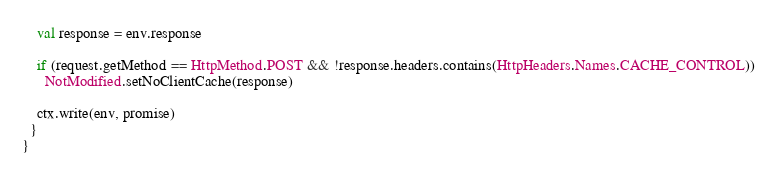Convert code to text. <code><loc_0><loc_0><loc_500><loc_500><_Scala_>    val response = env.response

    if (request.getMethod == HttpMethod.POST && !response.headers.contains(HttpHeaders.Names.CACHE_CONTROL))
      NotModified.setNoClientCache(response)

    ctx.write(env, promise)
  }
}
</code> 